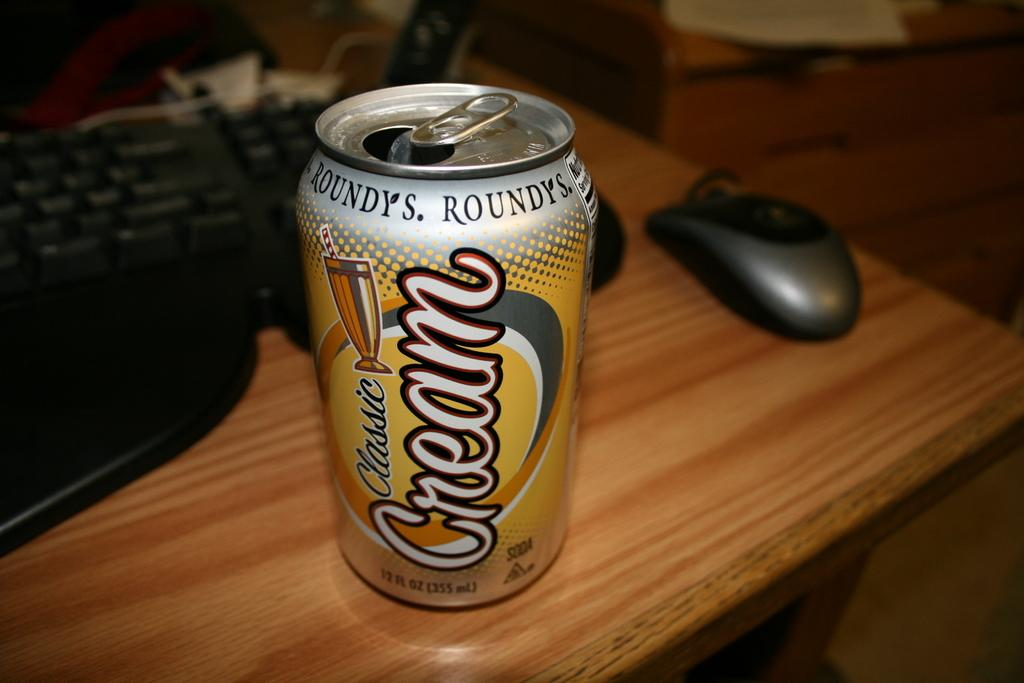<image>
Describe the image concisely. A can of Classic Cream soda is open and on the desk near a keyboard and mouse. 